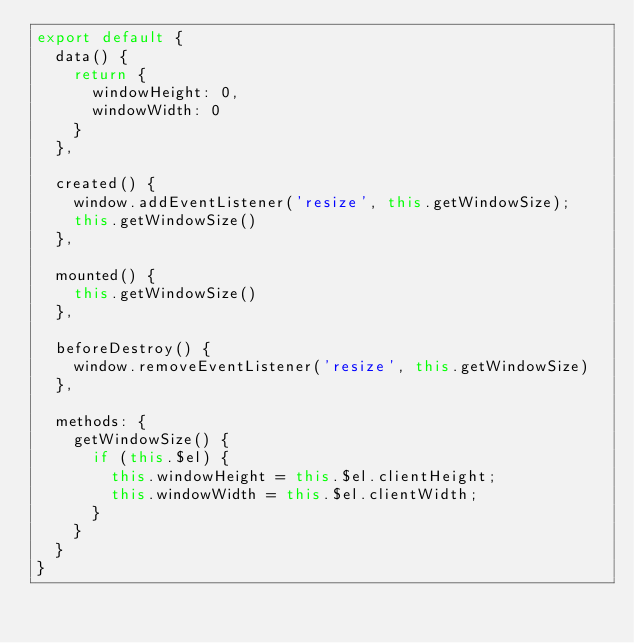<code> <loc_0><loc_0><loc_500><loc_500><_JavaScript_>export default {
  data() {
    return {
      windowHeight: 0,
      windowWidth: 0
    }
  },

  created() {
    window.addEventListener('resize', this.getWindowSize);
    this.getWindowSize()
  },

  mounted() {
    this.getWindowSize()
  },

  beforeDestroy() {
    window.removeEventListener('resize', this.getWindowSize)
  },

  methods: {
    getWindowSize() {
      if (this.$el) {
        this.windowHeight = this.$el.clientHeight;
        this.windowWidth = this.$el.clientWidth;
      }
    }
  }
}

</code> 